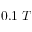Convert formula to latex. <formula><loc_0><loc_0><loc_500><loc_500>0 . 1 \, T</formula> 